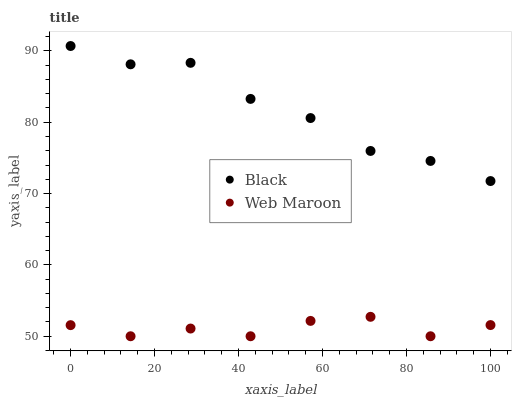Does Web Maroon have the minimum area under the curve?
Answer yes or no. Yes. Does Black have the maximum area under the curve?
Answer yes or no. Yes. Does Black have the minimum area under the curve?
Answer yes or no. No. Is Black the smoothest?
Answer yes or no. Yes. Is Web Maroon the roughest?
Answer yes or no. Yes. Is Black the roughest?
Answer yes or no. No. Does Web Maroon have the lowest value?
Answer yes or no. Yes. Does Black have the lowest value?
Answer yes or no. No. Does Black have the highest value?
Answer yes or no. Yes. Is Web Maroon less than Black?
Answer yes or no. Yes. Is Black greater than Web Maroon?
Answer yes or no. Yes. Does Web Maroon intersect Black?
Answer yes or no. No. 